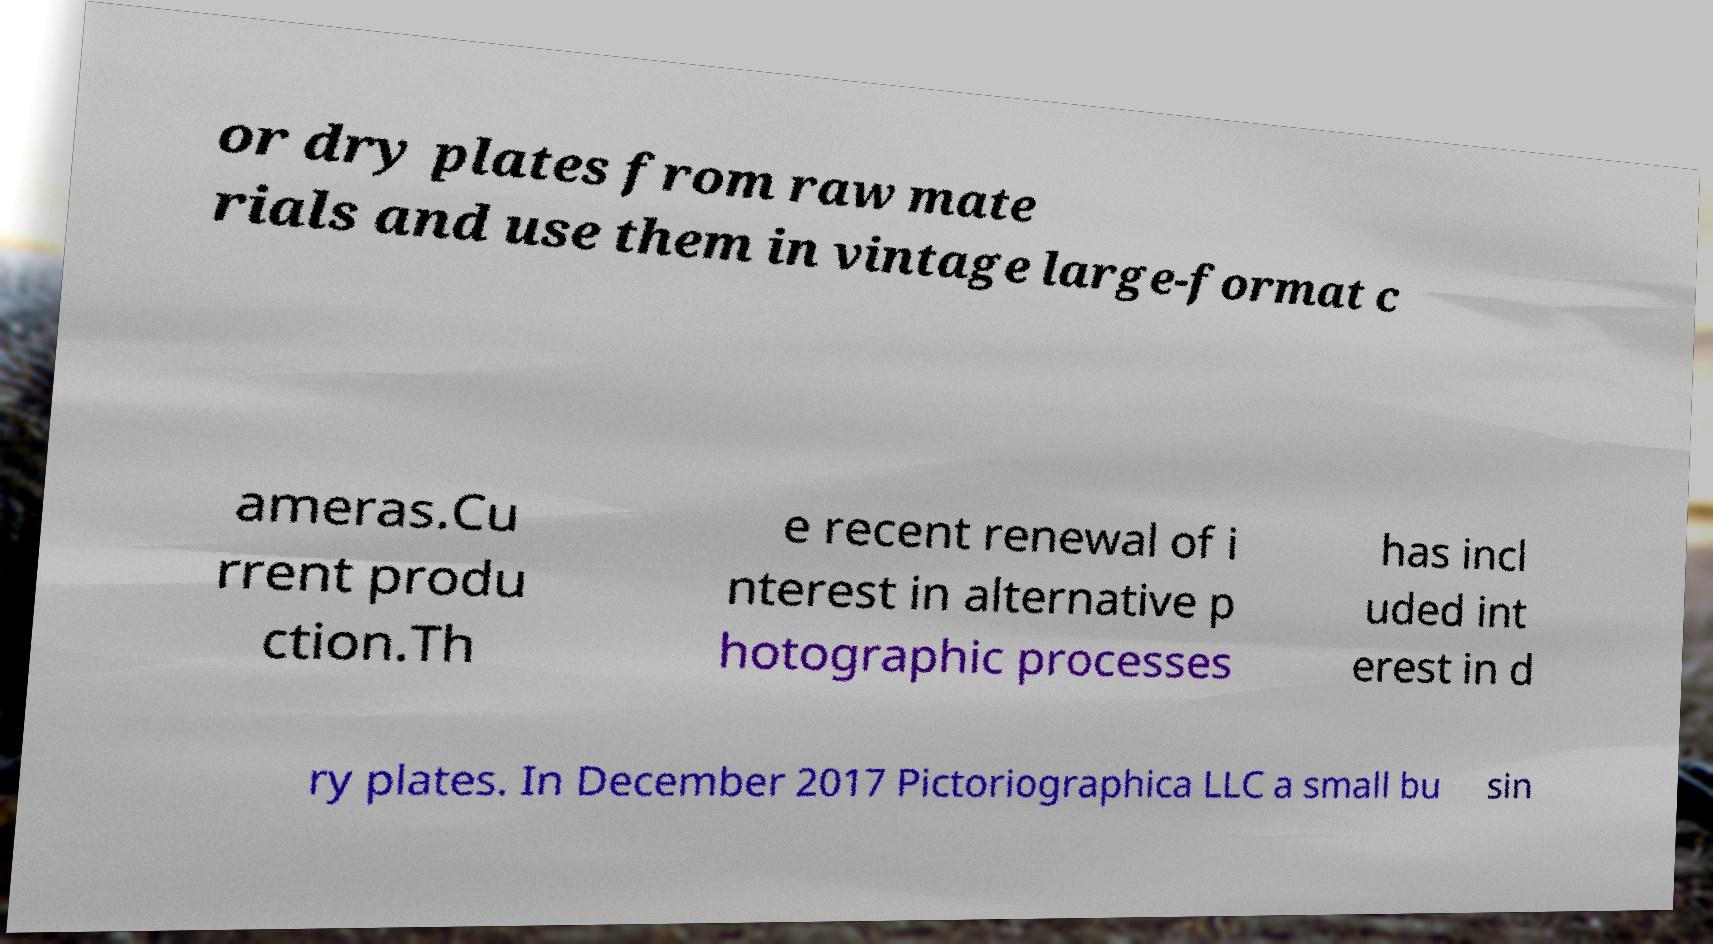There's text embedded in this image that I need extracted. Can you transcribe it verbatim? or dry plates from raw mate rials and use them in vintage large-format c ameras.Cu rrent produ ction.Th e recent renewal of i nterest in alternative p hotographic processes has incl uded int erest in d ry plates. In December 2017 Pictoriographica LLC a small bu sin 